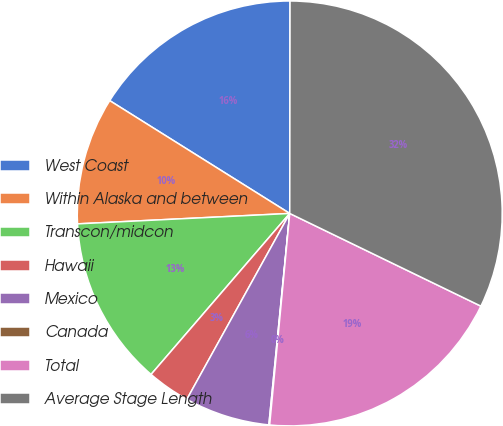Convert chart to OTSL. <chart><loc_0><loc_0><loc_500><loc_500><pie_chart><fcel>West Coast<fcel>Within Alaska and between<fcel>Transcon/midcon<fcel>Hawaii<fcel>Mexico<fcel>Canada<fcel>Total<fcel>Average Stage Length<nl><fcel>16.11%<fcel>9.69%<fcel>12.9%<fcel>3.27%<fcel>6.48%<fcel>0.06%<fcel>19.32%<fcel>32.16%<nl></chart> 